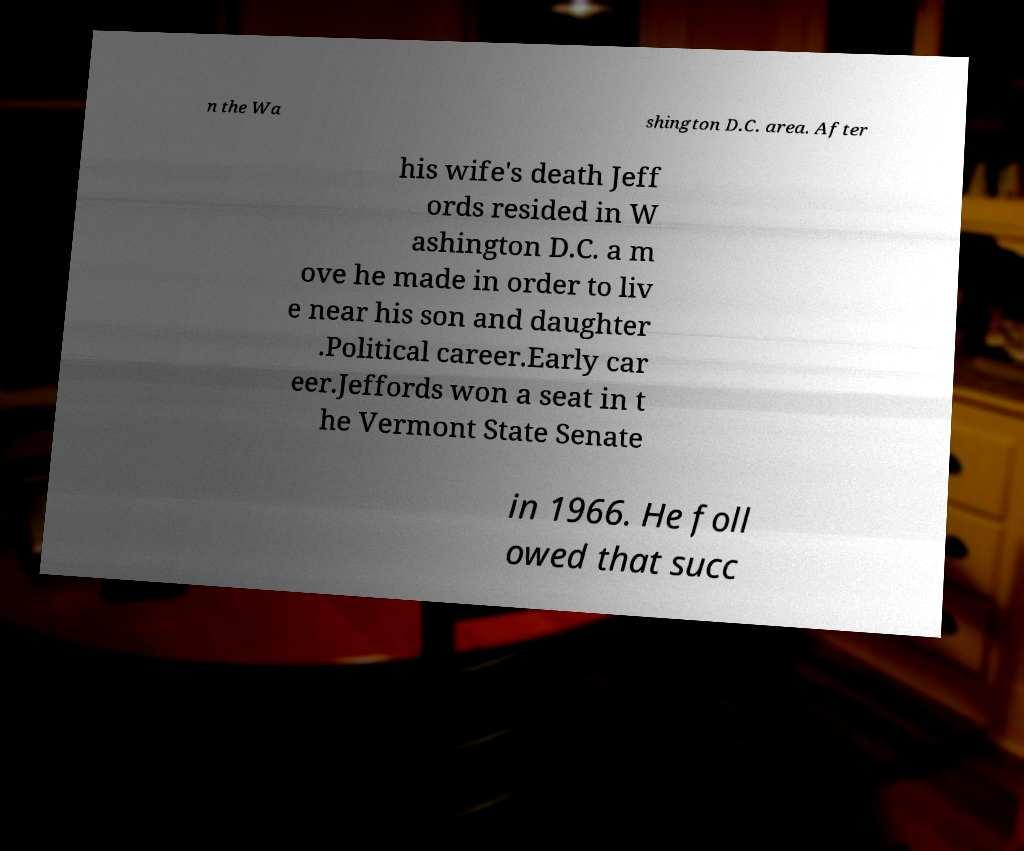Could you extract and type out the text from this image? n the Wa shington D.C. area. After his wife's death Jeff ords resided in W ashington D.C. a m ove he made in order to liv e near his son and daughter .Political career.Early car eer.Jeffords won a seat in t he Vermont State Senate in 1966. He foll owed that succ 